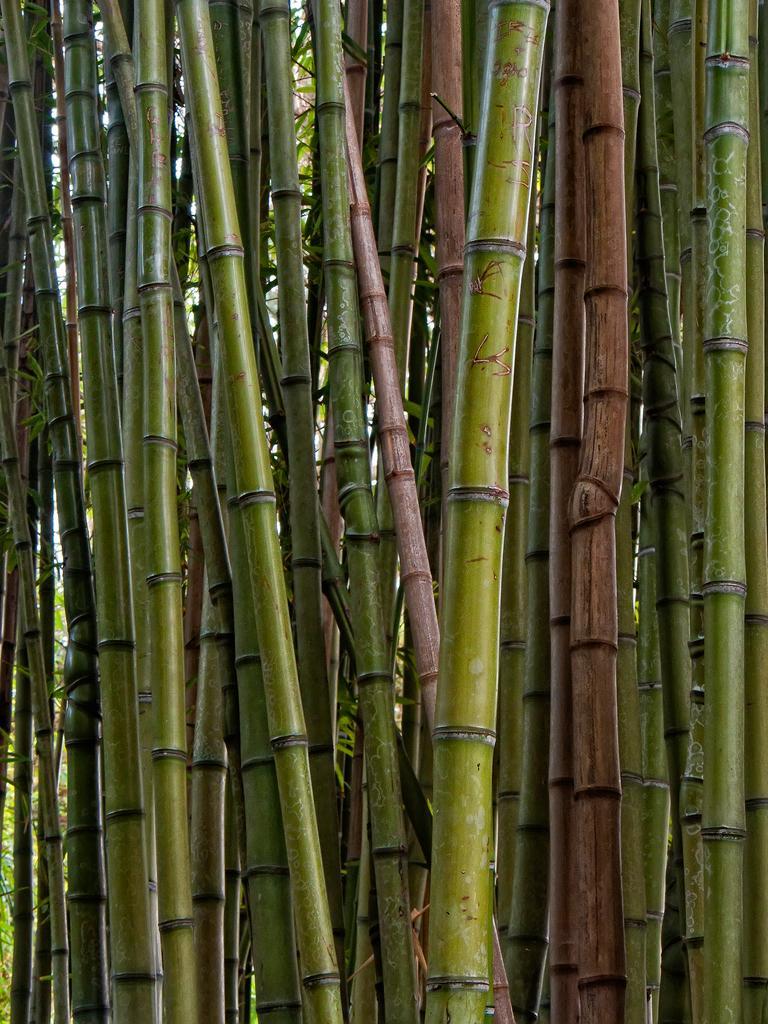How would you summarize this image in a sentence or two? In this image I can see number of bamboo sticks. 